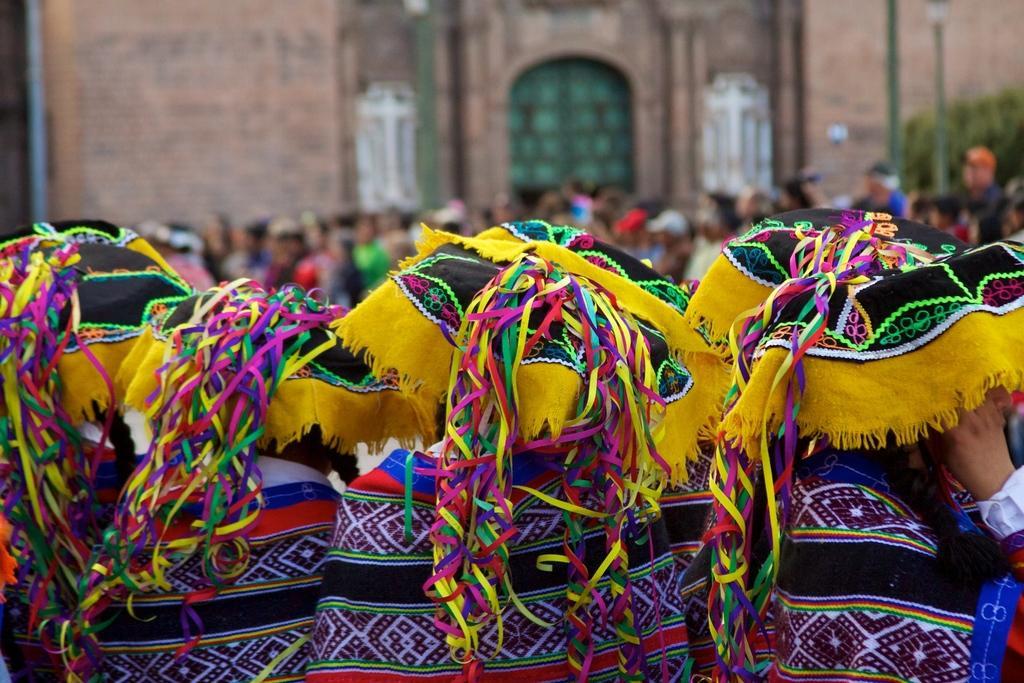Please provide a concise description of this image. In this image we can see few persons, some of them are wearing different costumes, also we can see a building, poles, plants, and the background is blurred. 